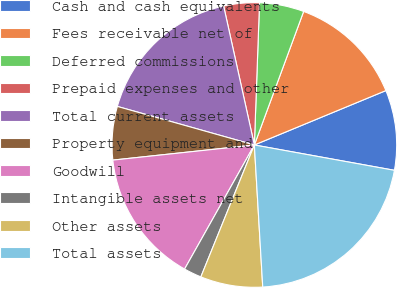<chart> <loc_0><loc_0><loc_500><loc_500><pie_chart><fcel>Cash and cash equivalents<fcel>Fees receivable net of<fcel>Deferred commissions<fcel>Prepaid expenses and other<fcel>Total current assets<fcel>Property equipment and<fcel>Goodwill<fcel>Intangible assets net<fcel>Other assets<fcel>Total assets<nl><fcel>9.09%<fcel>13.13%<fcel>5.05%<fcel>4.04%<fcel>17.17%<fcel>6.06%<fcel>15.15%<fcel>2.02%<fcel>7.07%<fcel>21.21%<nl></chart> 